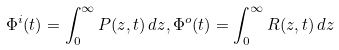Convert formula to latex. <formula><loc_0><loc_0><loc_500><loc_500>\Phi ^ { i } ( t ) = \int _ { 0 } ^ { \infty } P ( z , t ) \, d z , \Phi ^ { o } ( t ) = \int _ { 0 } ^ { \infty } R ( z , t ) \, d z</formula> 